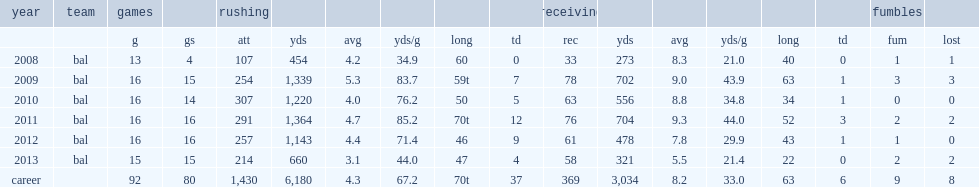Hoa many rushing yards did rice finish the 2010 season with? 1220.0. 